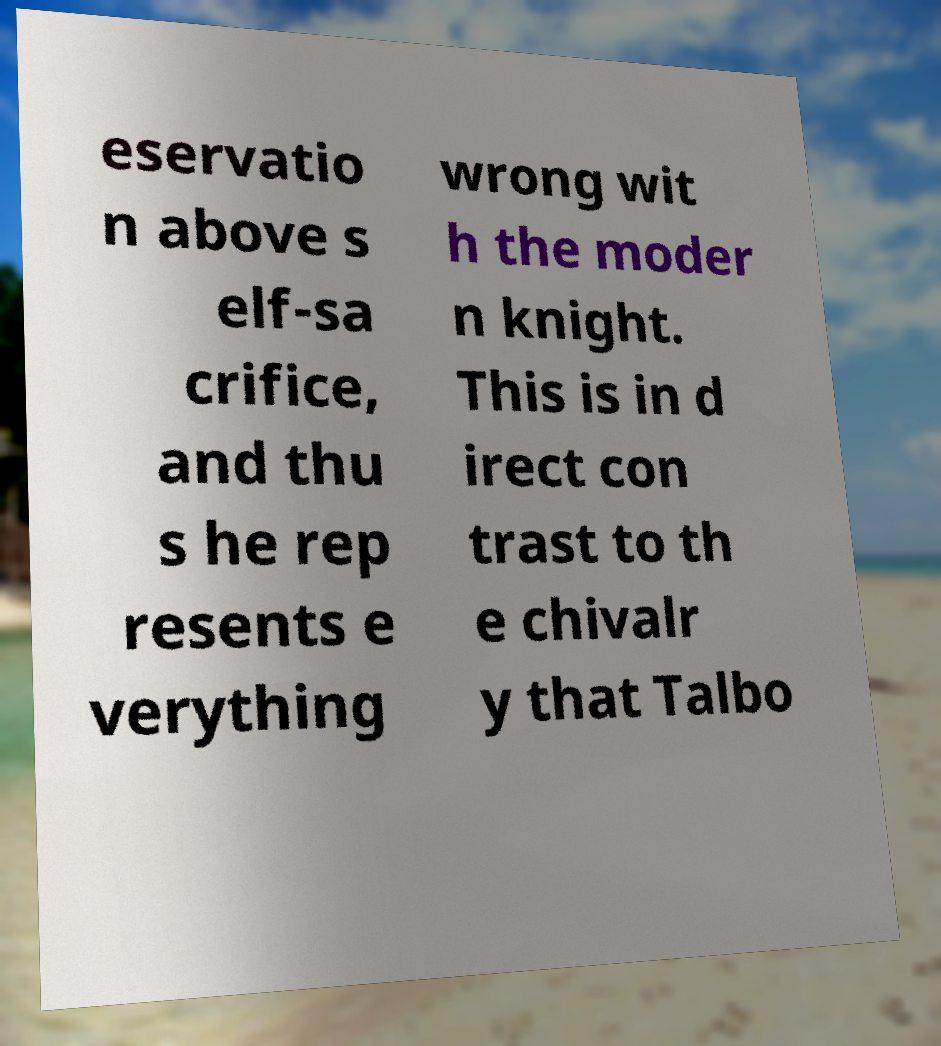There's text embedded in this image that I need extracted. Can you transcribe it verbatim? eservatio n above s elf-sa crifice, and thu s he rep resents e verything wrong wit h the moder n knight. This is in d irect con trast to th e chivalr y that Talbo 